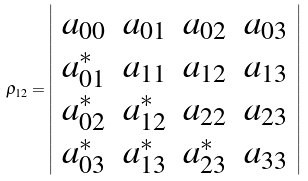<formula> <loc_0><loc_0><loc_500><loc_500>\rho _ { 1 2 } = \left | \begin{array} { c c c c } a _ { 0 0 } & a _ { 0 1 } & a _ { 0 2 } & a _ { 0 3 } \\ a _ { 0 1 } ^ { * } & a _ { 1 1 } & a _ { 1 2 } & a _ { 1 3 } \\ a _ { 0 2 } ^ { * } & a _ { 1 2 } ^ { * } & a _ { 2 2 } & a _ { 2 3 } \\ a _ { 0 3 } ^ { * } & a _ { 1 3 } ^ { * } & a _ { 2 3 } ^ { * } & a _ { 3 3 } \end{array} \right |</formula> 